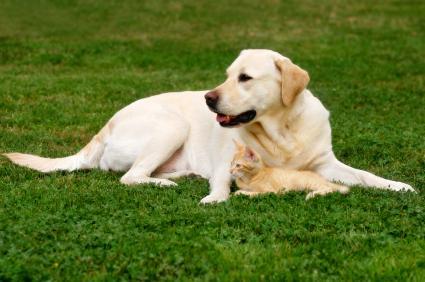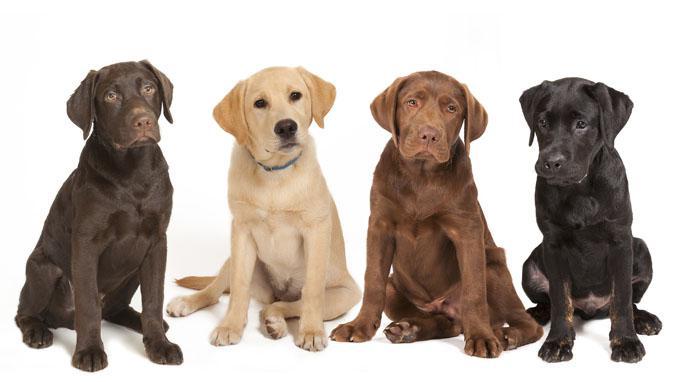The first image is the image on the left, the second image is the image on the right. For the images shown, is this caption "In at least one image there are exactly two dogs outside together." true? Answer yes or no. No. The first image is the image on the left, the second image is the image on the right. Analyze the images presented: Is the assertion "There are two dogs in the left picture." valid? Answer yes or no. No. 